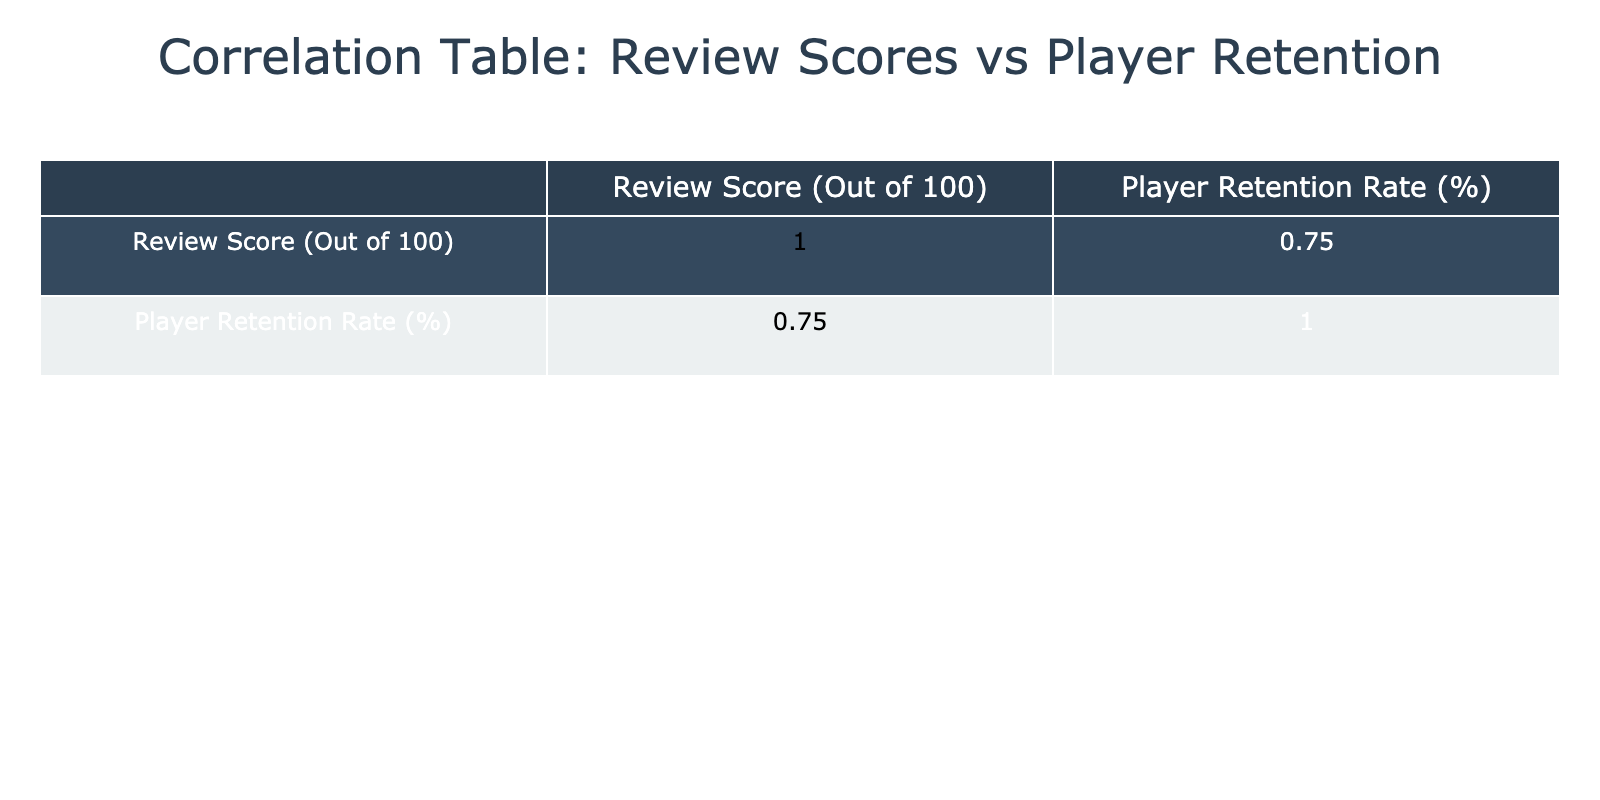What is the review score for Genshin Impact? The table lists Genshin Impact with a review score of 87. This value is directly visible in the "Review Score (Out of 100)" column next to the game's title.
Answer: 87 What is the player retention rate for Animal Crossing: New Horizons? Animal Crossing: New Horizons has a player retention rate of 95%, which can be found in the "Player Retention Rate (%)" column for this title in the table.
Answer: 95% What is the average review score of all games listed? First, we add the review scores: 93 + 89 + 77 + 92 + 91 + 87 + 89 + 85 + 82 + 86 =  881. There are 10 games, so we divide 881 by 10, resulting in an average of 88.1.
Answer: 88.1 Is the player retention rate for Cyberpunk 2077 higher than 65%? The player retention rate for Cyberpunk 2077 is 60%, which is lower than 65%. This can be checked in the respective row for the game in the table.
Answer: No Which game has the highest player retention rate, and what is that rate? By comparing the "Player Retention Rate (%)" values in the table, Animal Crossing: New Horizons has the highest player retention rate of 95%. This is found by scanning the percentage values in the column and identifying the maximum.
Answer: Animal Crossing: New Horizons, 95% What is the difference in player retention rates between Hades and Apex Legends? Hades has a player retention rate of 90%, while Apex Legends has a retention rate of 75%. The difference is calculated by subtracting 75 from 90, which equals 15.
Answer: 15 Are there any games with a review score below 80 that have a player retention rate above 70%? Yes, Cyberpunk 2077 has a review score of 77 and a player retention rate of 60%, and Ghost of Tsushima has a review score of 82 and a retention rate of 80%. Ghost of Tsushima meets the criterion but Cyberpunk 2077 does not. Thus, the answer is no, as the only qualifying game does not exist.
Answer: No What is the sum of the player retention rates for games with a review score above 85? The games with a review score above 85 are The Last of Us Part II (85), Hades (90), Animal Crossing: New Horizons (95), Genshin Impact (83), and Fortnite (88). Their player retention rates are 85, 90, 95, 83, and 88, respectively. Adding these gives: 85 + 90 + 95 + 83 + 88 = 441.
Answer: 441 